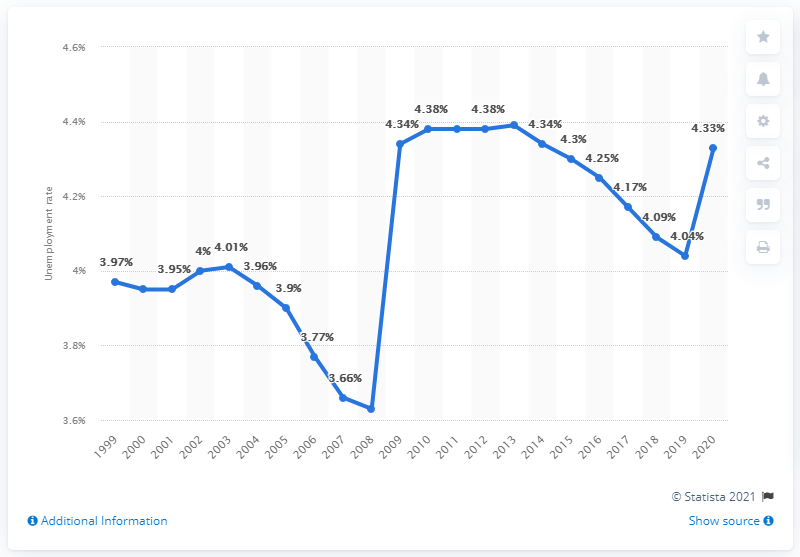Highlight a few significant elements in this photo. The unemployment rate in the Central African Republic in 2020 was 4.33%. 